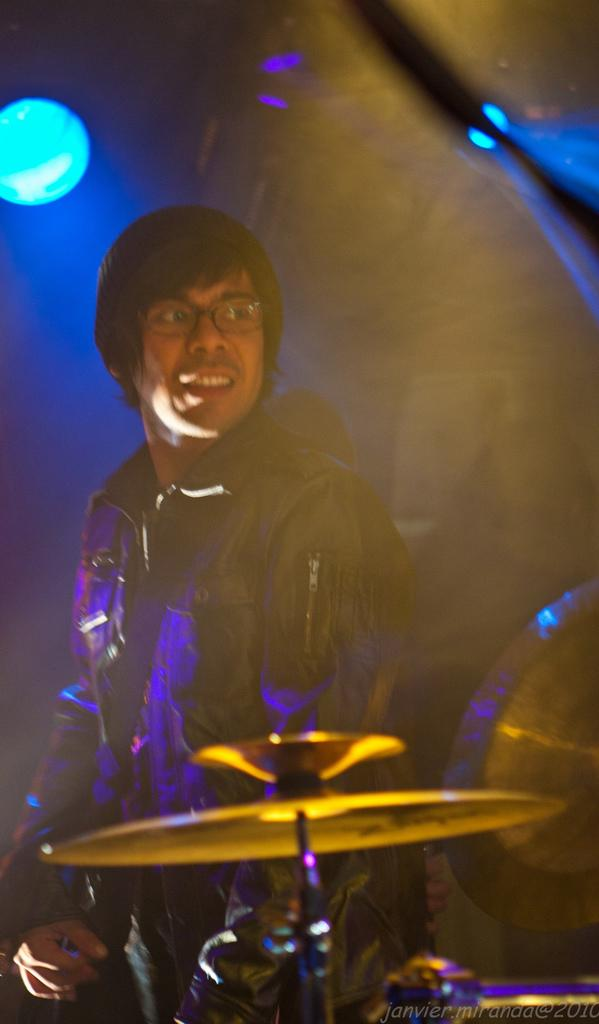What is the main subject in the image? There is a person in the image. Can you describe the lighting in the image? There is light in the image. What type of music is present in the image? Jazz is present in the image. How would you describe the background of the image? The background of the image is blurred. What type of song is being sung by the fan in the image? There is no fan present in the image, and therefore no such singing activity can be observed. How does the carriage help the person in the image? There is no carriage present in the image, so it cannot help the person in any way. 